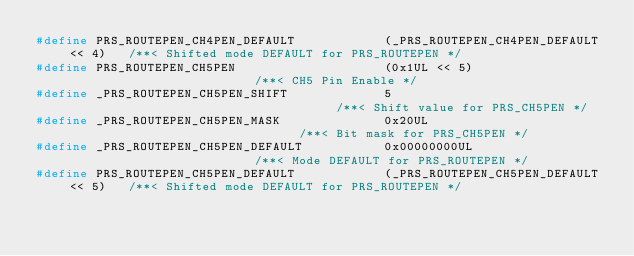Convert code to text. <code><loc_0><loc_0><loc_500><loc_500><_C_>#define PRS_ROUTEPEN_CH4PEN_DEFAULT            (_PRS_ROUTEPEN_CH4PEN_DEFAULT << 4)   /**< Shifted mode DEFAULT for PRS_ROUTEPEN */
#define PRS_ROUTEPEN_CH5PEN                    (0x1UL << 5)                          /**< CH5 Pin Enable */
#define _PRS_ROUTEPEN_CH5PEN_SHIFT             5                                     /**< Shift value for PRS_CH5PEN */
#define _PRS_ROUTEPEN_CH5PEN_MASK              0x20UL                                /**< Bit mask for PRS_CH5PEN */
#define _PRS_ROUTEPEN_CH5PEN_DEFAULT           0x00000000UL                          /**< Mode DEFAULT for PRS_ROUTEPEN */
#define PRS_ROUTEPEN_CH5PEN_DEFAULT            (_PRS_ROUTEPEN_CH5PEN_DEFAULT << 5)   /**< Shifted mode DEFAULT for PRS_ROUTEPEN */</code> 